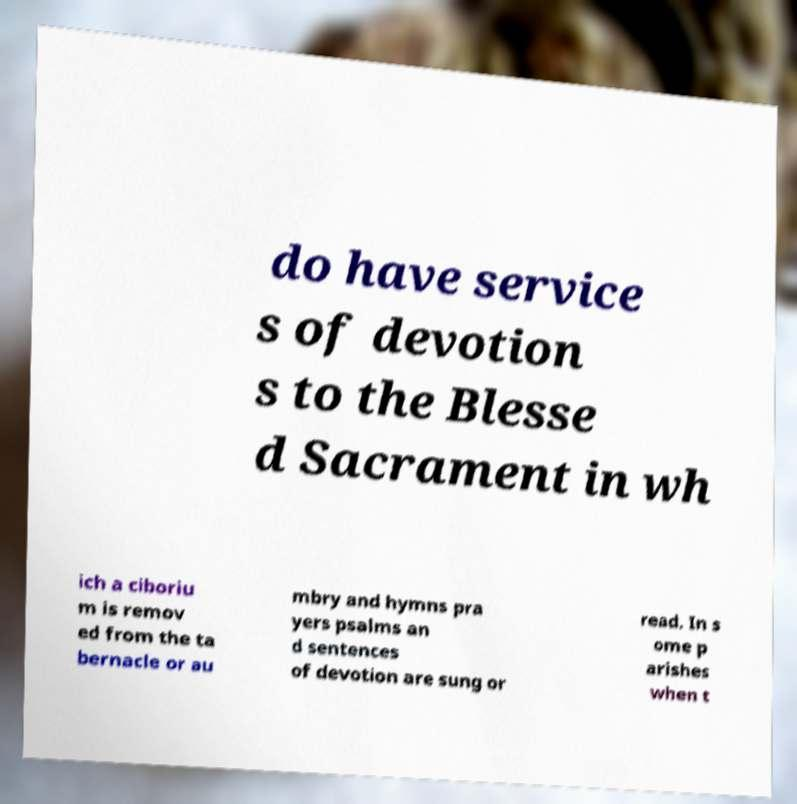What messages or text are displayed in this image? I need them in a readable, typed format. do have service s of devotion s to the Blesse d Sacrament in wh ich a ciboriu m is remov ed from the ta bernacle or au mbry and hymns pra yers psalms an d sentences of devotion are sung or read. In s ome p arishes when t 